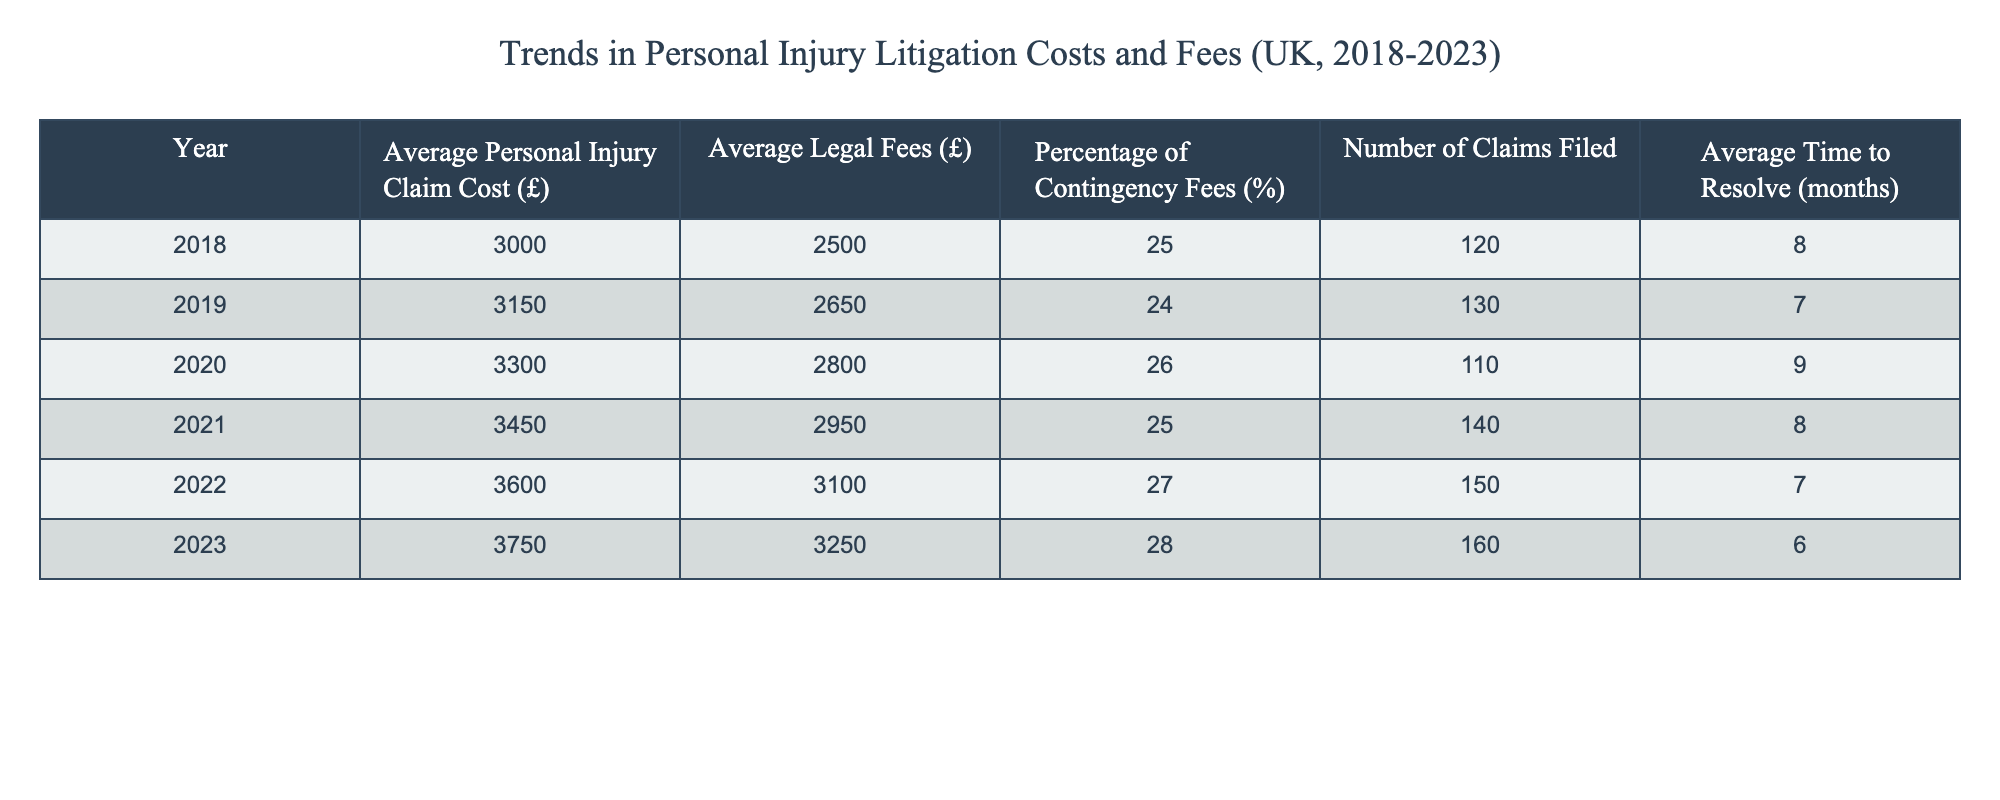What was the average personal injury claim cost in 2020? The table shows the average personal injury claim cost for each year. For 2020, the value listed under that year is £3300.
Answer: £3300 What year had the highest number of claims filed? By reviewing the "Number of Claims Filed" column, we can see that 2023 had the highest value with 160 claims filed.
Answer: 2023 What was the percentage increase in average legal fees from 2018 to 2023? The average legal fees in 2018 were £2500, and in 2023, they are £3250. The increase is £3250 - £2500 = £750. To find the percentage increase, we calculate (750 / 2500) * 100, which equals 30%.
Answer: 30% Did the average time to resolve claims increase or decrease from 2018 to 2023? In 2018, the average time to resolve claims was 8 months, while in 2023, it decreased to 6 months. This indicates a decrease.
Answer: Decrease What is the average contingency fee percentage over the selected years? To find the average, we sum the percentages for each year: (25 + 24 + 26 + 25 + 27 + 28) = 155. Then divide by the number of years, 6. Thus, average contingency fee percentage is 155 / 6 ≈ 25.83%.
Answer: 25.83% Which year had the lowest average time to resolve claims? The average time to resolve claims needs to be compared across the years. The time in 2023 is 6 months, which is the lowest among all the years listed.
Answer: 2023 By how much did the average personal injury claim cost change from 2019 to 2021? We find the average personal injury claim costs for 2019 (£3150) and 2021 (£3450). The change is £3450 - £3150 = £300.
Answer: £300 What is the trend of average personal injury claim costs over the years? By examining the costs across all years, from 2018 to 2023, it consistently increases each year: from £3000 to £3750. This indicates an upward trend.
Answer: Upward trend 